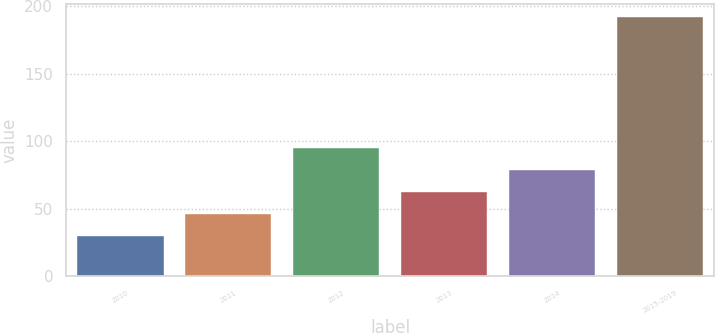Convert chart. <chart><loc_0><loc_0><loc_500><loc_500><bar_chart><fcel>2010<fcel>2011<fcel>2012<fcel>2013<fcel>2014<fcel>2015-2019<nl><fcel>30.1<fcel>46.29<fcel>94.86<fcel>62.48<fcel>78.67<fcel>192<nl></chart> 